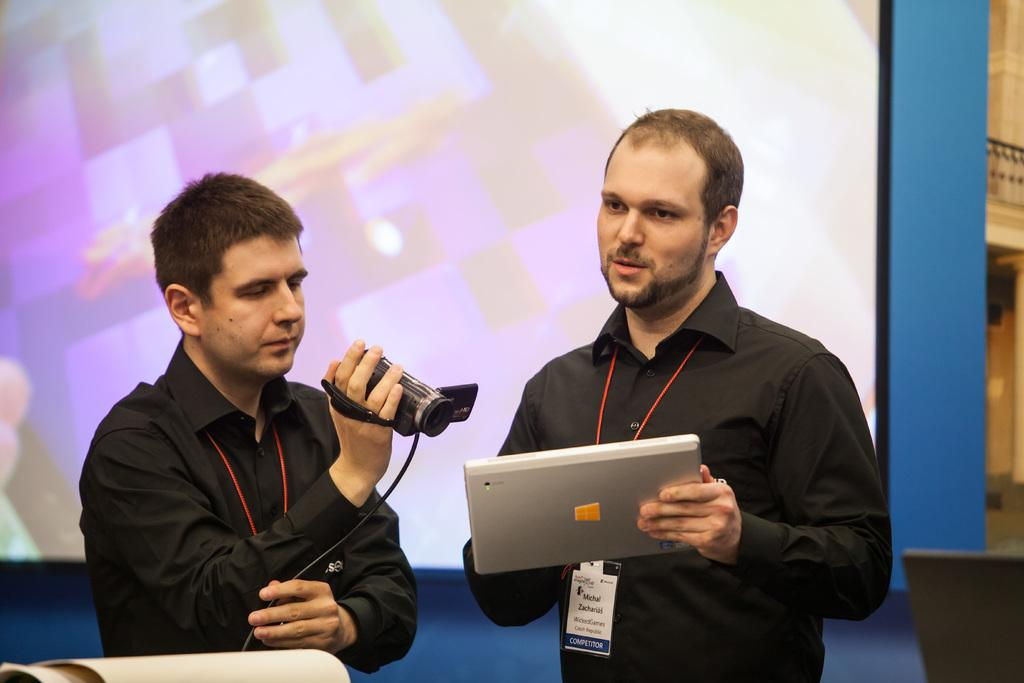How many men are present in the image? There are men standing in the image. What objects are the men holding? One man is holding a laptop, and another man is holding a video camera. What can be seen on the wall in the image? There is a projector screen on the wall in the image. How many ducks are visible on the projector screen in the image? There are no ducks visible on the projector screen in the image. What type of partner is standing next to the man holding the laptop? There is no mention of a partner or any other person standing next to the man holding the laptop in the image. 